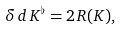<formula> <loc_0><loc_0><loc_500><loc_500>\delta \, d \, K ^ { \flat } = 2 \, R ( K ) ,</formula> 